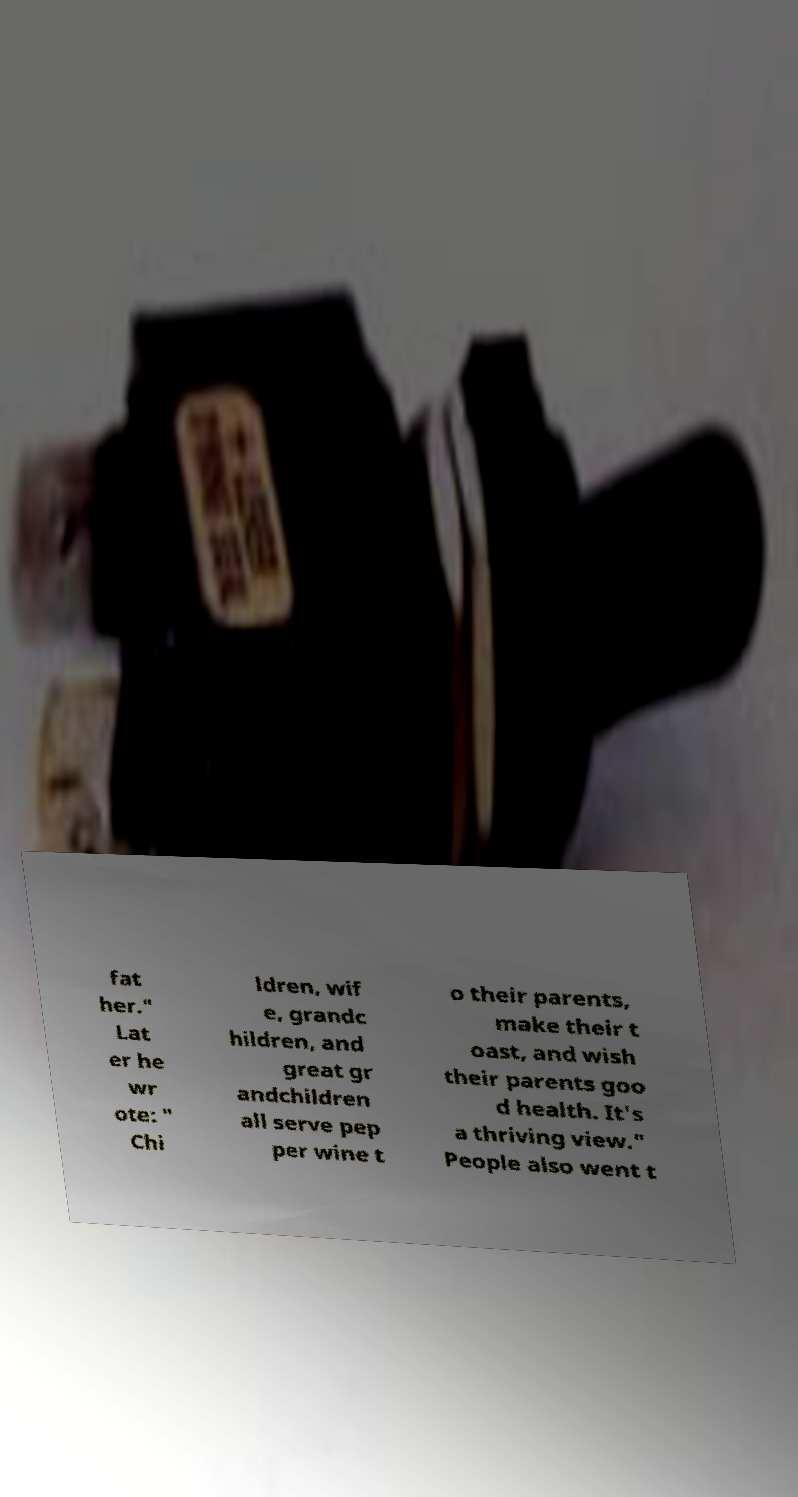Can you accurately transcribe the text from the provided image for me? fat her." Lat er he wr ote: " Chi ldren, wif e, grandc hildren, and great gr andchildren all serve pep per wine t o their parents, make their t oast, and wish their parents goo d health. It's a thriving view." People also went t 